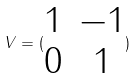<formula> <loc_0><loc_0><loc_500><loc_500>V = ( \begin{matrix} 1 & - 1 \\ 0 & 1 \end{matrix} )</formula> 